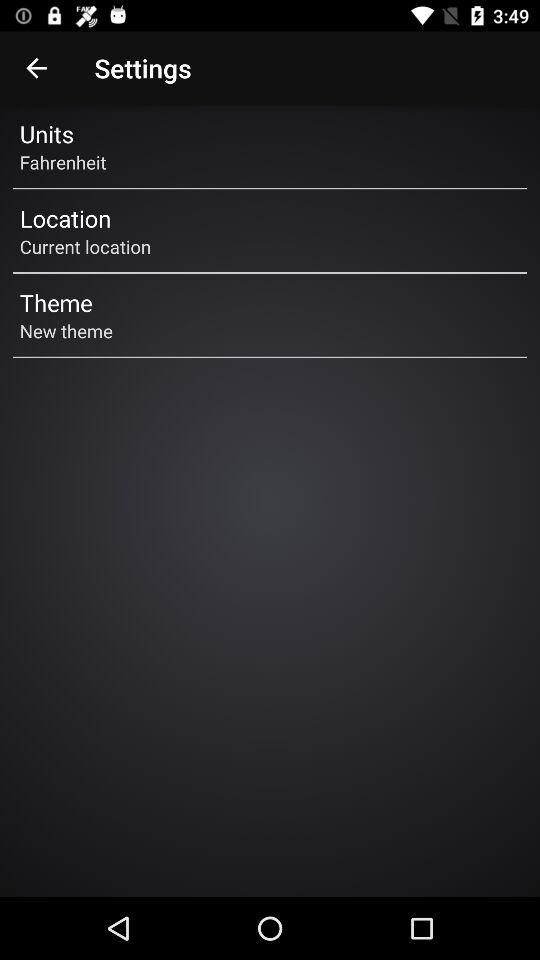What's the "Units"? The "Units" is "Fahrenheit". 